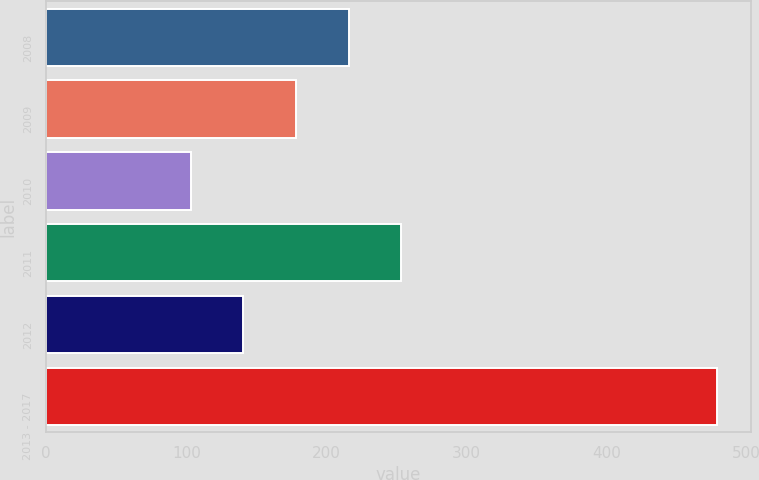Convert chart to OTSL. <chart><loc_0><loc_0><loc_500><loc_500><bar_chart><fcel>2008<fcel>2009<fcel>2010<fcel>2011<fcel>2012<fcel>2013 - 2017<nl><fcel>215.8<fcel>178.2<fcel>103<fcel>253.4<fcel>140.6<fcel>479<nl></chart> 